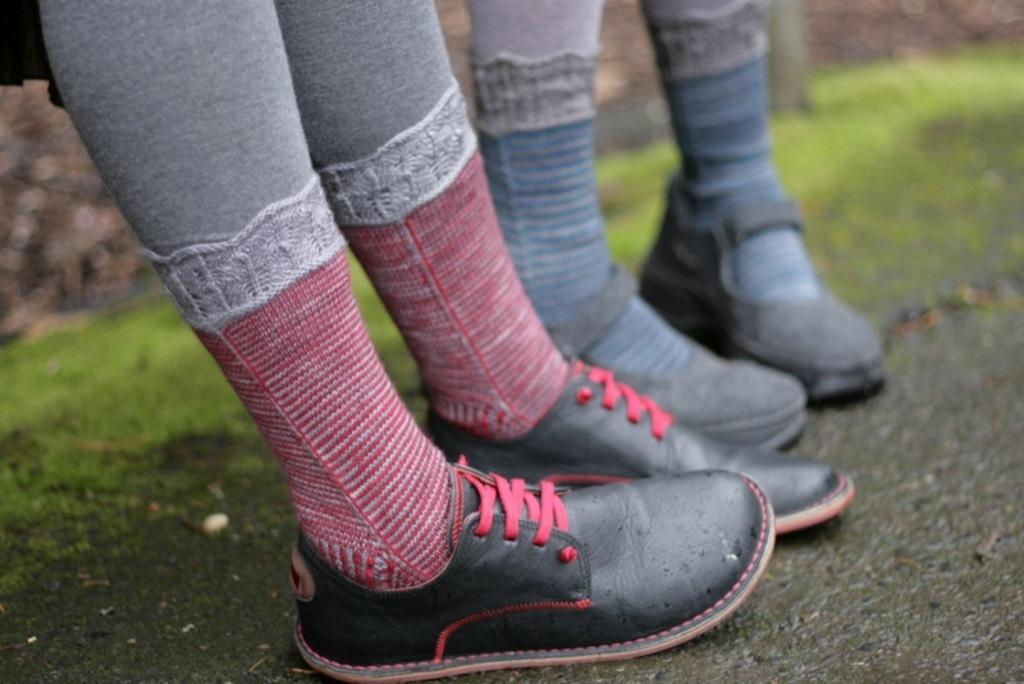What part of a person or animal can be seen in the image? There are legs visible in the image. What type of environment is behind the legs in the image? There is grass behind the legs in the image. Are the sisters in harmony while holding the paper in the image? There is no mention of sisters or paper in the image; only legs and grass are present. 